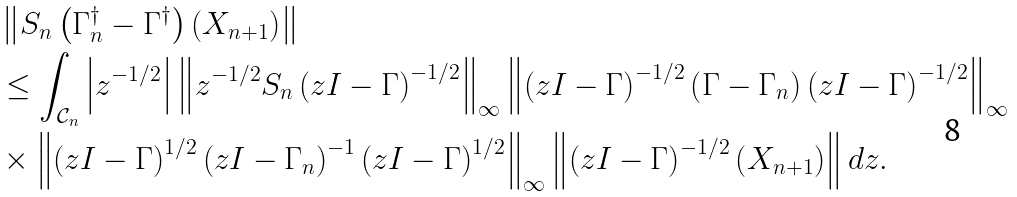<formula> <loc_0><loc_0><loc_500><loc_500>& \left \| S _ { n } \left ( \Gamma _ { n } ^ { \dagger } - \Gamma ^ { \dagger } \right ) \left ( X _ { n + 1 } \right ) \right \| \\ & \leq \int _ { \mathcal { C } _ { n } } \left | z ^ { - 1 / 2 } \right | \left \| z ^ { - 1 / 2 } S _ { n } \left ( z I - \Gamma \right ) ^ { - 1 / 2 } \right \| _ { \infty } \left \| \left ( z I - \Gamma \right ) ^ { - 1 / 2 } \left ( \Gamma - \Gamma _ { n } \right ) \left ( z I - \Gamma \right ) ^ { - 1 / 2 } \right \| _ { \infty } \\ & \times \left \| \left ( z I - \Gamma \right ) ^ { 1 / 2 } \left ( z I - \Gamma _ { n } \right ) ^ { - 1 } \left ( z I - \Gamma \right ) ^ { 1 / 2 } \right \| _ { \infty } \left \| \left ( z I - \Gamma \right ) ^ { - 1 / 2 } \left ( X _ { n + 1 } \right ) \right \| d z .</formula> 